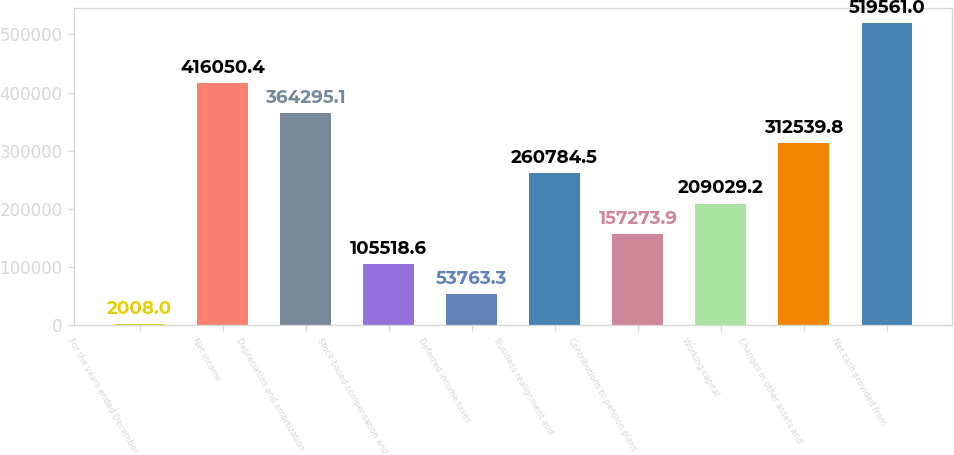Convert chart. <chart><loc_0><loc_0><loc_500><loc_500><bar_chart><fcel>For the years ended December<fcel>Net income<fcel>Depreciation and amortization<fcel>Stock-based compensation and<fcel>Deferred income taxes<fcel>Business realignment and<fcel>Contributions to pension plans<fcel>Working capital<fcel>Changes in other assets and<fcel>Net cash provided from<nl><fcel>2008<fcel>416050<fcel>364295<fcel>105519<fcel>53763.3<fcel>260784<fcel>157274<fcel>209029<fcel>312540<fcel>519561<nl></chart> 